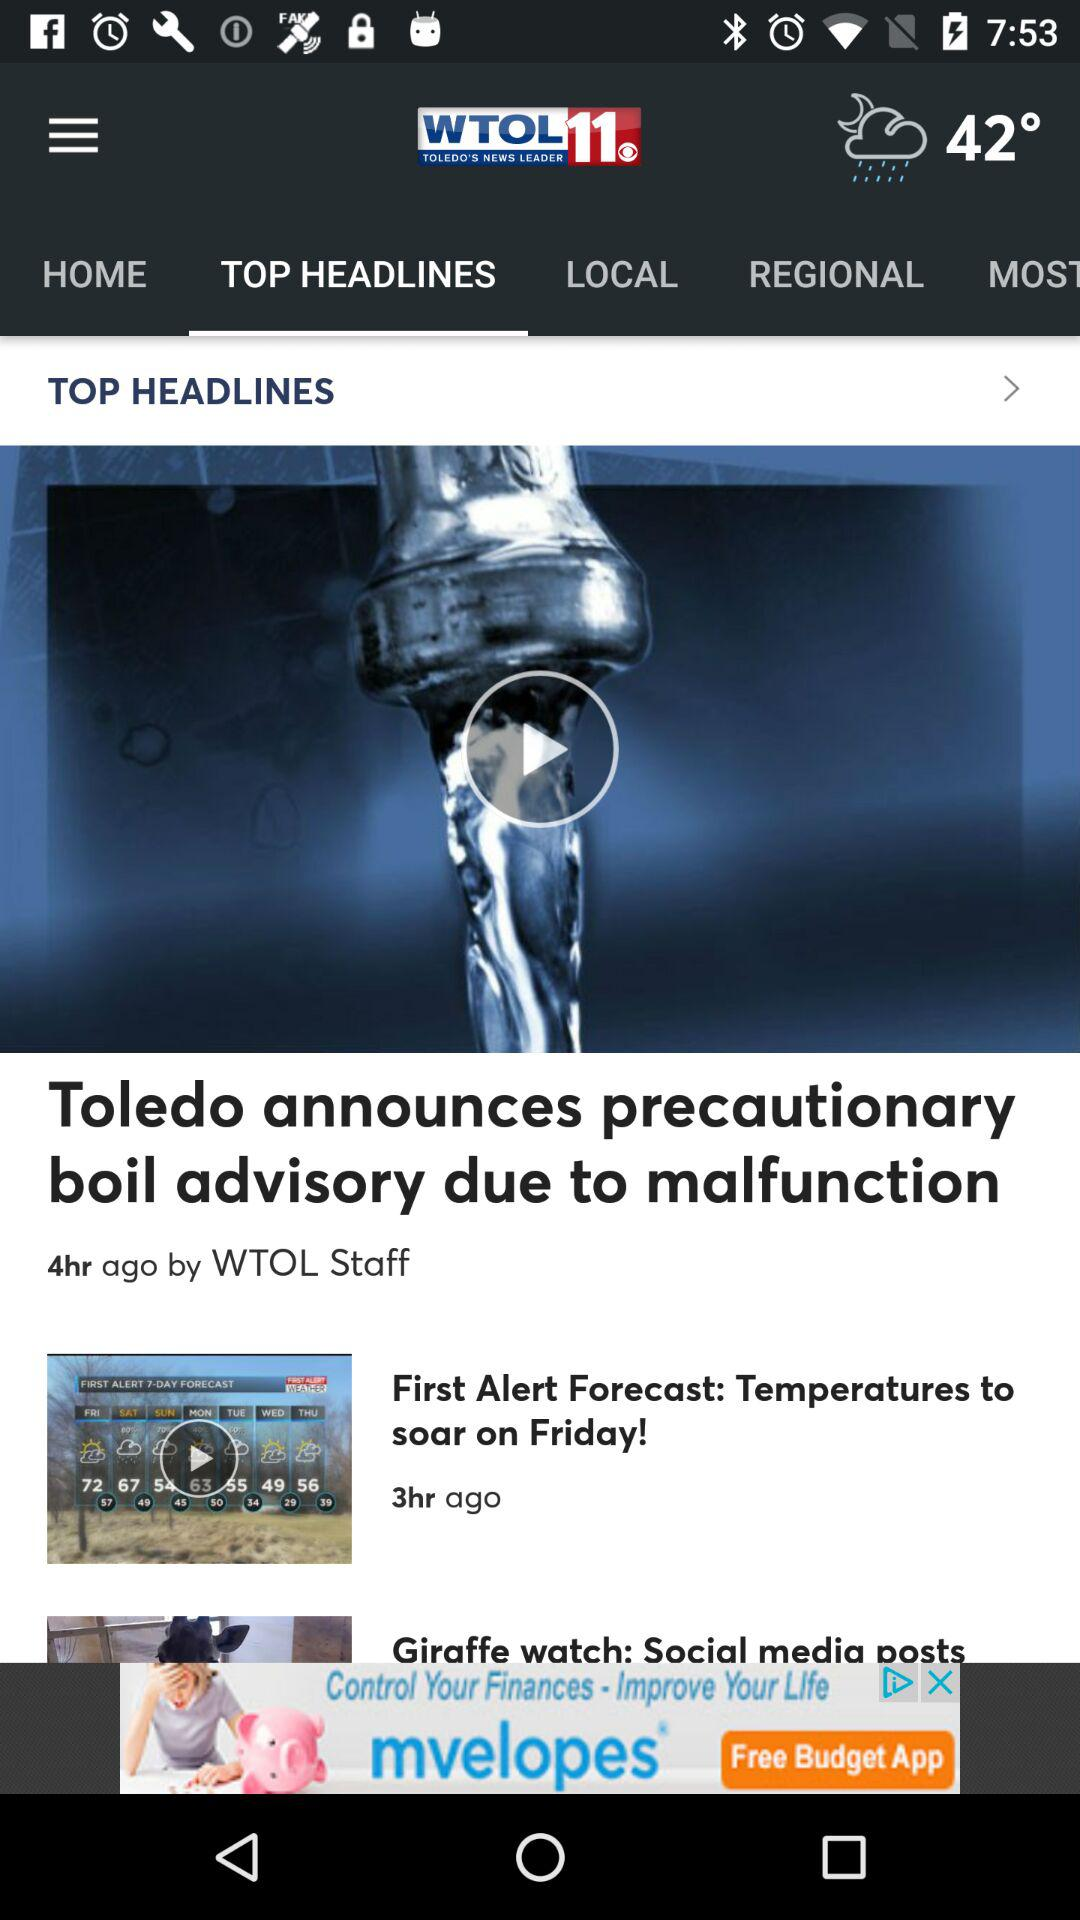How many hours ago was the first alert forecast published?
Answer the question using a single word or phrase. 3 